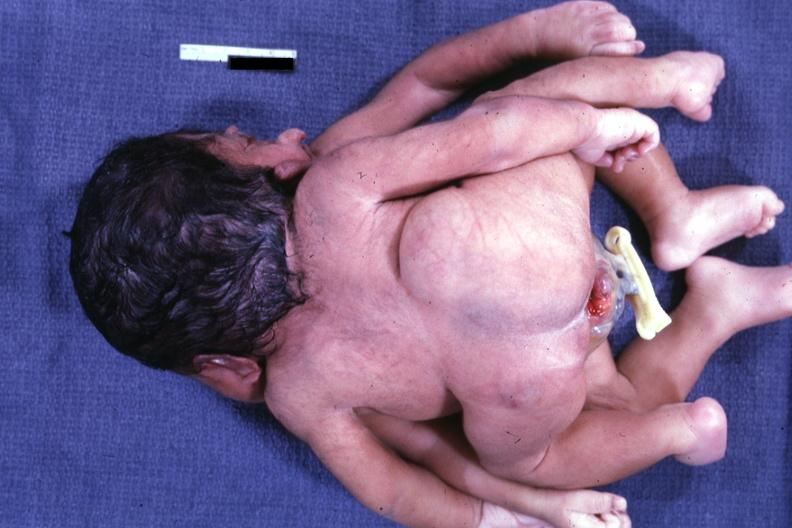what is view of twin joined?
Answer the question using a single word or phrase. At head and chest 